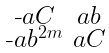Convert formula to latex. <formula><loc_0><loc_0><loc_500><loc_500>\begin{smallmatrix} \text {-} a C & a b \\ \text {-} a b ^ { 2 m } & a C \end{smallmatrix}</formula> 